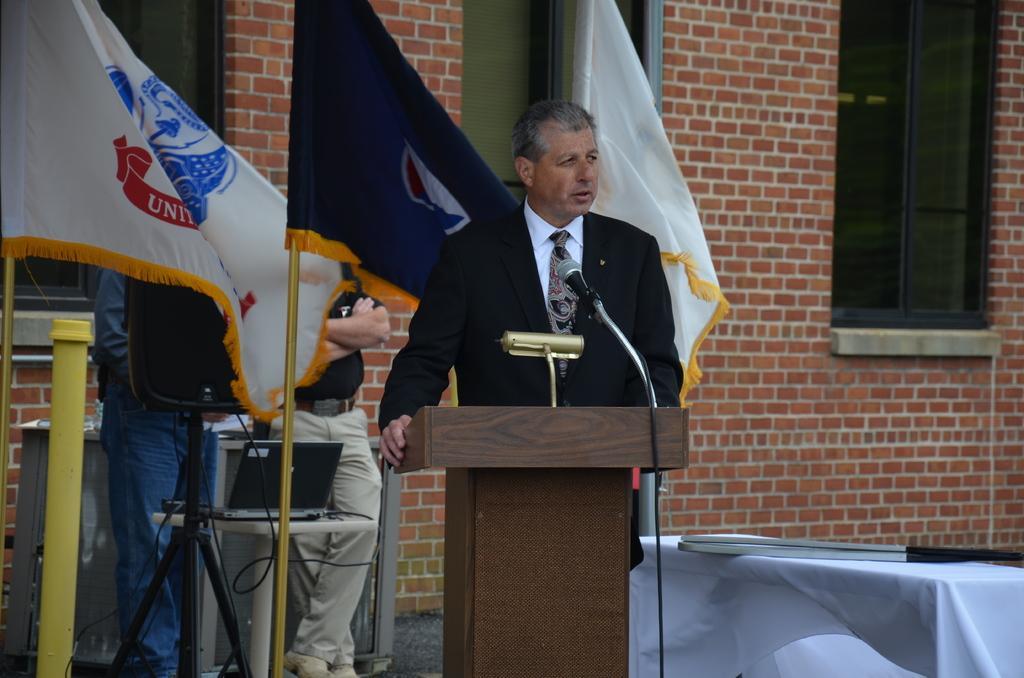In one or two sentences, can you explain what this image depicts? As we can see in the image there is a brick wall, window, table, flags, three people standing, mic and there is a laptop. 